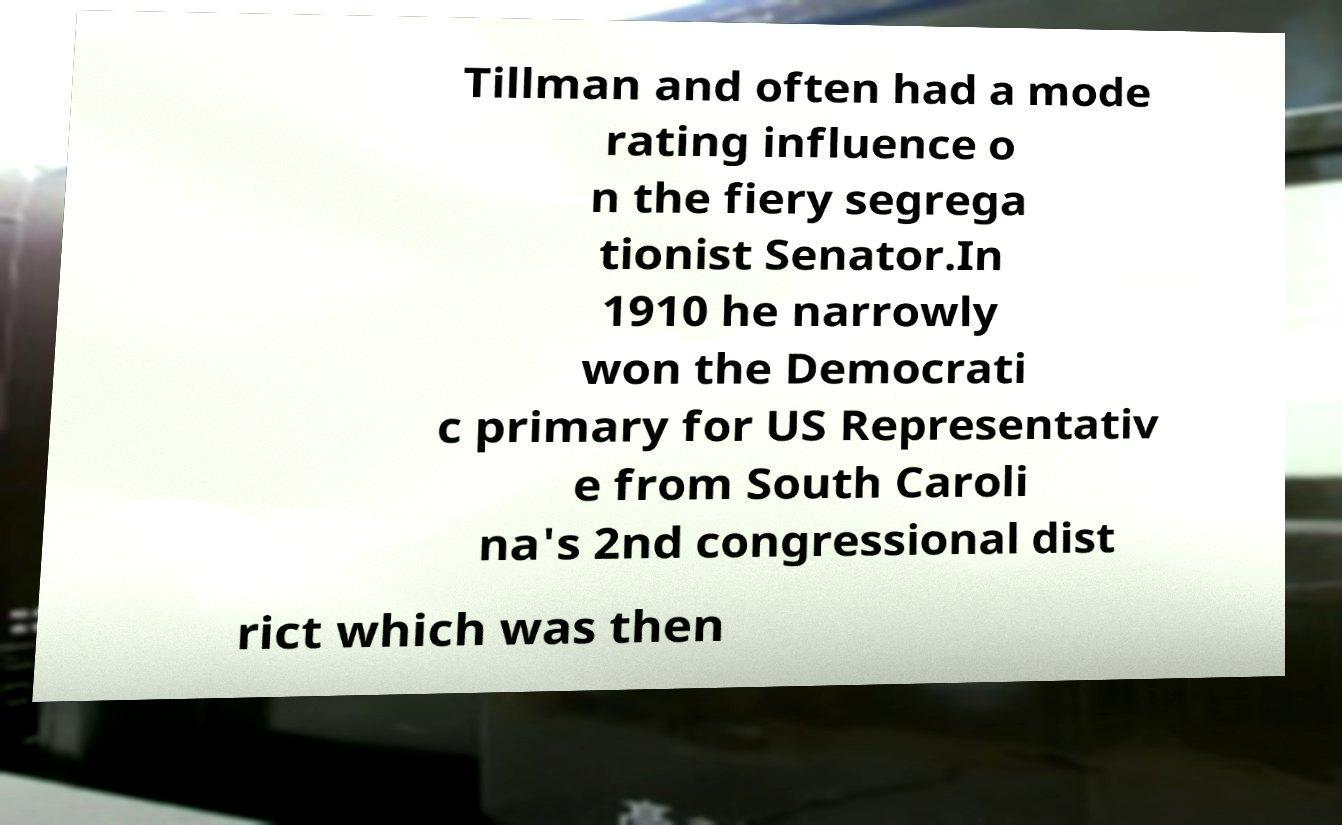Please read and relay the text visible in this image. What does it say? Tillman and often had a mode rating influence o n the fiery segrega tionist Senator.In 1910 he narrowly won the Democrati c primary for US Representativ e from South Caroli na's 2nd congressional dist rict which was then 